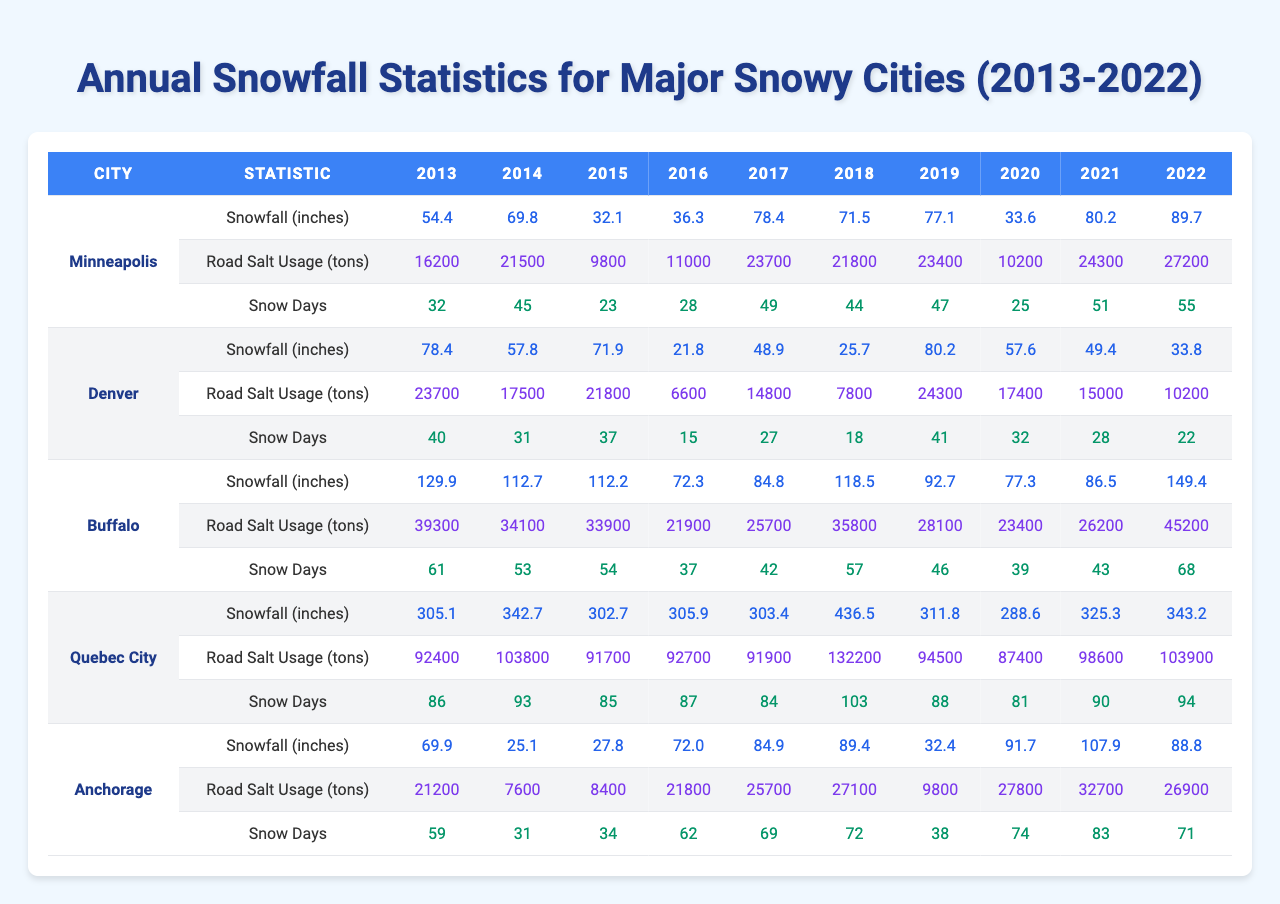What city had the highest annual snowfall in 2022? The table shows that Quebec City recorded 343.2 inches of snowfall in 2022, which is higher than any other city listed.
Answer: Quebec City Which year did Buffalo experience its lowest snowfall? By reviewing the table, we can see that in 2016, Buffalo had the lowest recorded snowfall of 72.3 inches.
Answer: 2016 How many snow days did Minneapolis have in 2021? The table indicates that Minneapolis had 51 snow days in 2021, as per the data provided.
Answer: 51 What was the average snowfall for Denver over the past decade? To calculate the average, we sum Denver's snowfall from 2013 to 2022: 78.4 + 57.8 + 71.9 + 21.8 + 48.9 + 25.7 + 80.2 + 57.6 + 49.4 + 33.8 = 525.1. Dividing this by 10 gives an average of 52.51 inches.
Answer: 52.5 Did Quebec City have more than 300 inches of snowfall every year? Looking at the table, every recorded year shows snowfall totals well over 300 inches, confirming the statement as true.
Answer: Yes What year did Anchorage have the highest road salt usage? The data reveals that in 2022, Anchorage used 32,700 tons of road salt, the highest amount over the last decade.
Answer: 2022 Which city had the most snow days in 2018? Upon checking the table, Buffalo recorded 57 snow days in 2018, more than any other city that year.
Answer: Buffalo What was the difference in snowfall between Minneapolis in 2022 and 2013? For Minneapolis, the snowfall in 2022 was 89.7 inches, and in 2013 it was 54.4 inches. The difference is 89.7 - 54.4 = 35.3 inches.
Answer: 35.3 How many snow days did Quebec City have on average over the last decade? Adding up the snow days from 2013 to 2022 gives us 86 + 93 + 85 + 87 + 84 + 103 + 88 + 81 + 90 + 94 = 1009. Dividing by 10, we find the average is 100.9.
Answer: 100.9 Did Denver have more snow days than Minneapolis in 2017? The table shows that Denver had 27 snow days, while Minneapolis had 49 snow days in 2017, meaning the statement is false.
Answer: No 